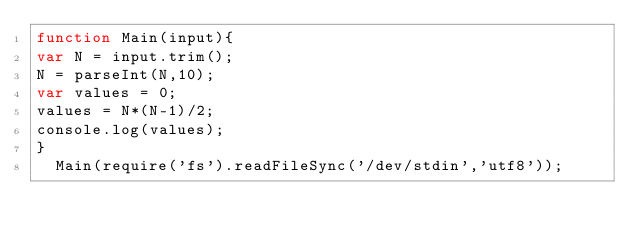Convert code to text. <code><loc_0><loc_0><loc_500><loc_500><_JavaScript_>function Main(input){
var N = input.trim();
N = parseInt(N,10);
var values = 0;
values = N*(N-1)/2;
console.log(values);
}
  Main(require('fs').readFileSync('/dev/stdin','utf8'));</code> 